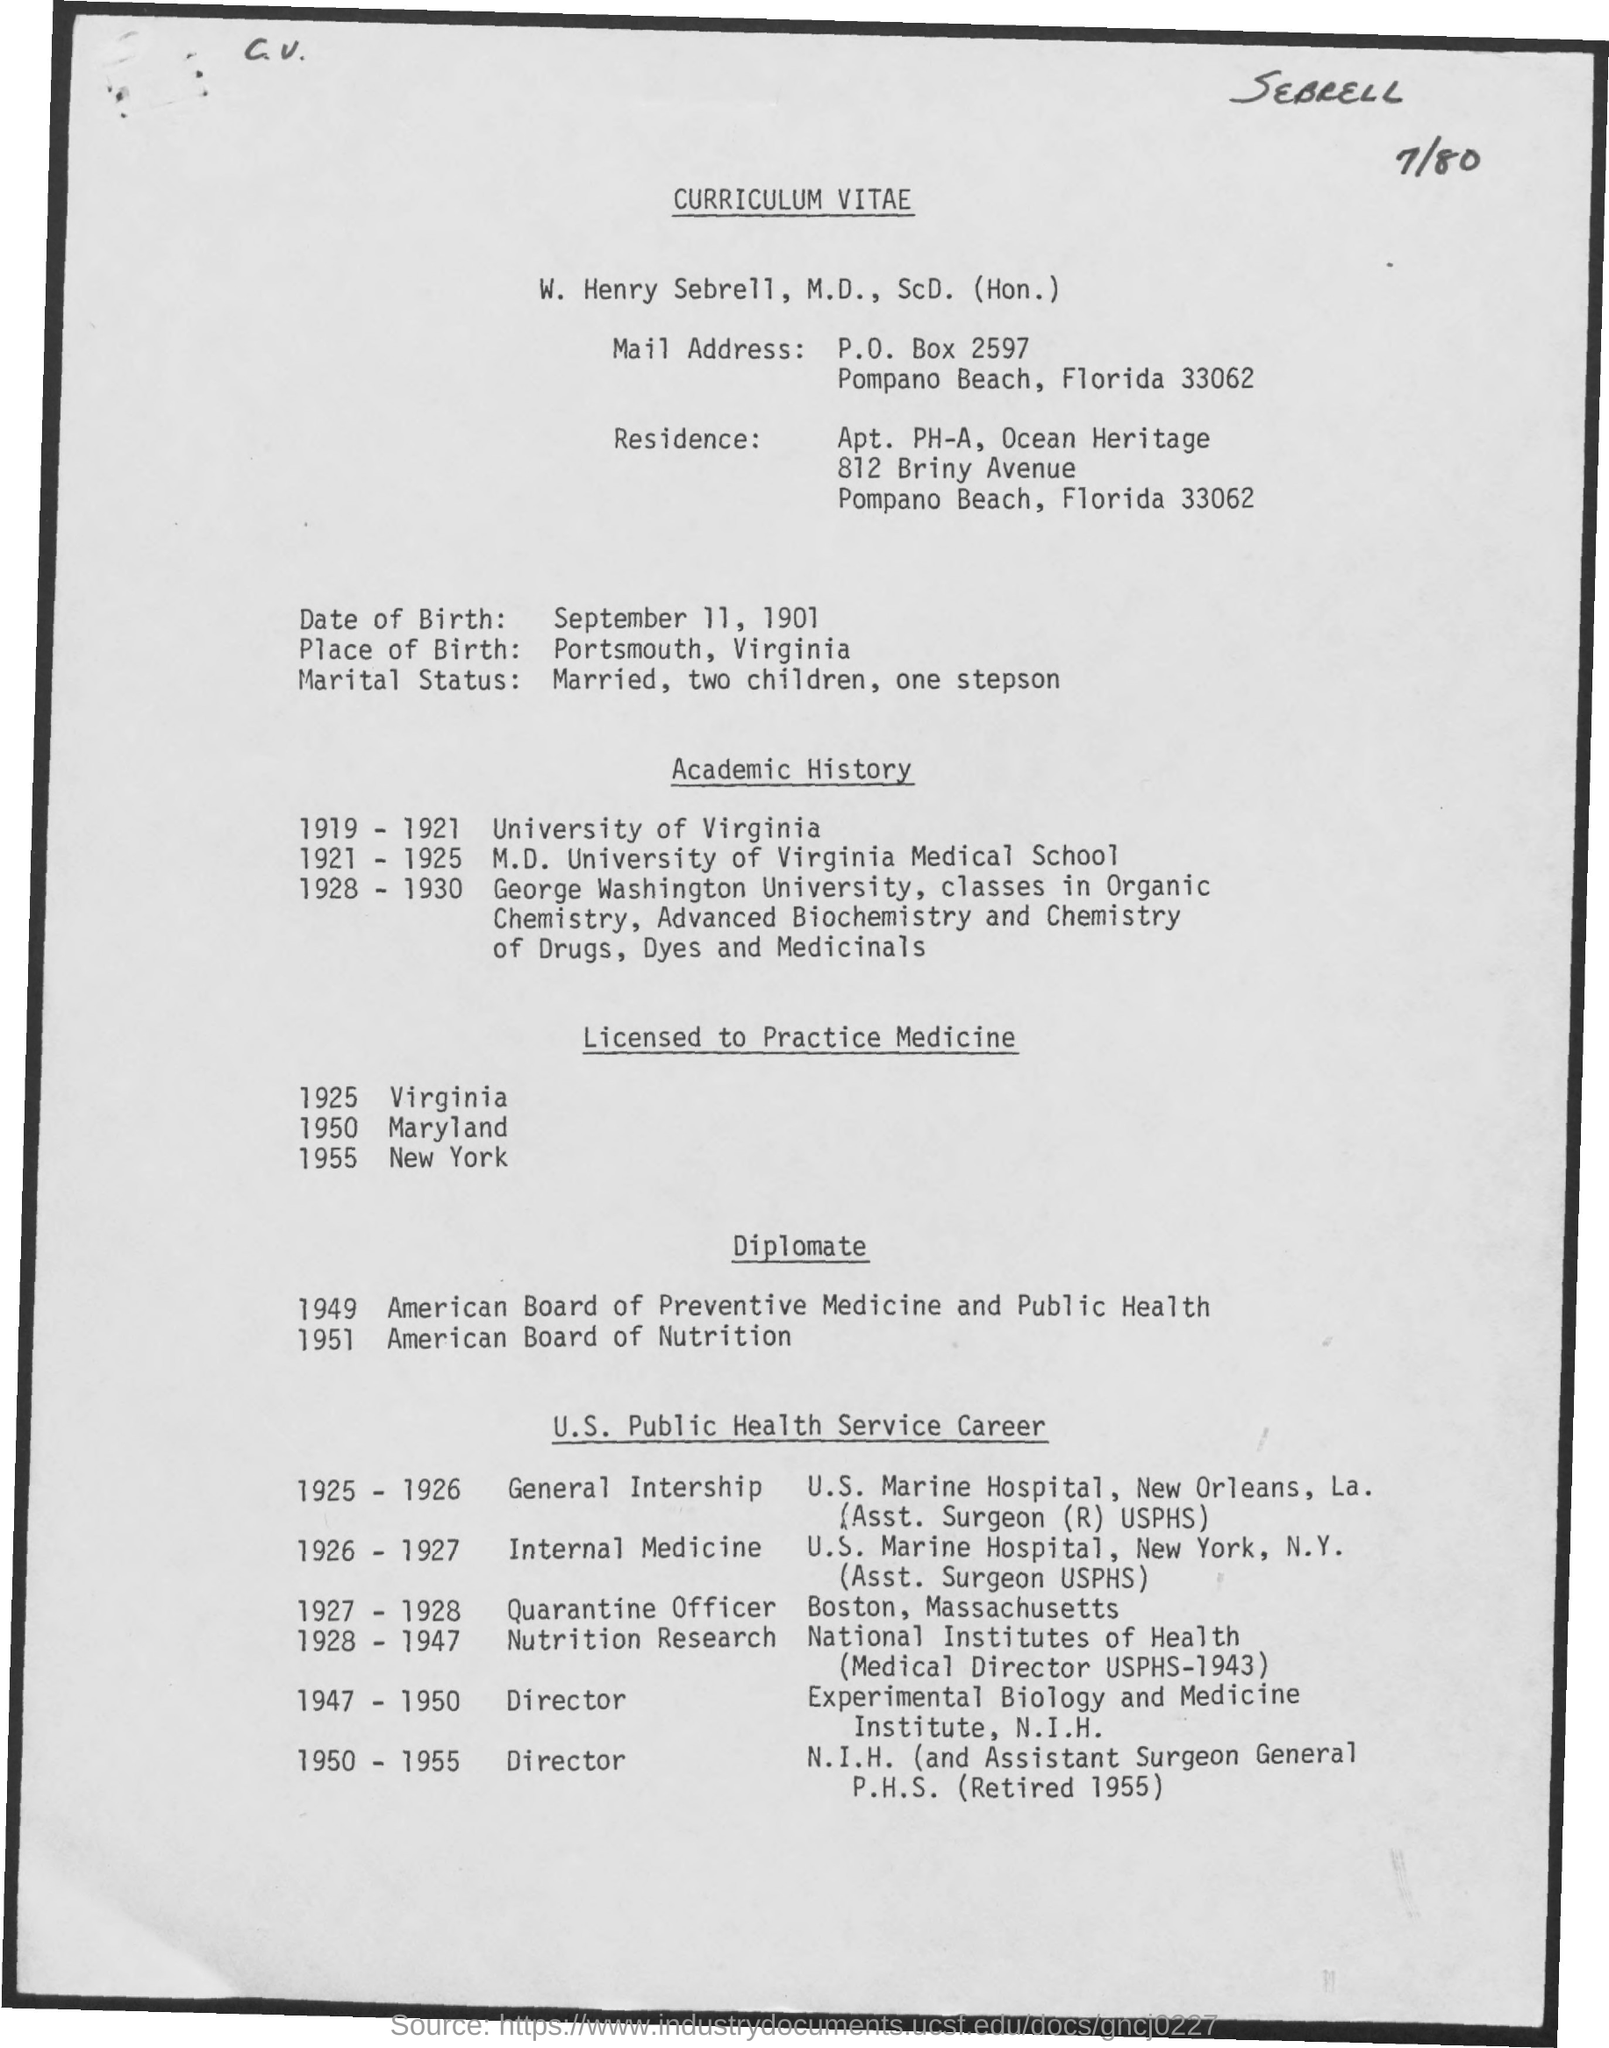Draw attention to some important aspects in this diagram. The person named W. Henry Sebrell is the one whose curriculum vitae is provided. In 1925, Dr. W. Henry Sebrell, who held both a medical degree and a doctorate in science, was licensed to practice medicine in the state of Virginia. W. Henry Sebrell, M.D., ScD. (Hon.), was licensed to practice medicine in Maryland in 1950. William Henry Sebrell, M.D., ScD. (Hon.), was born in Portsmouth, Virginia. On January 1, 1955, W. Henry Sebrell, M.D., ScD. (Hon.), was granted a license to practice medicine in the state of New York. 